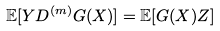Convert formula to latex. <formula><loc_0><loc_0><loc_500><loc_500>\mathbb { E } [ Y D ^ { ( m ) } G ( X ) ] = \mathbb { E } [ G ( X ) Z ]</formula> 